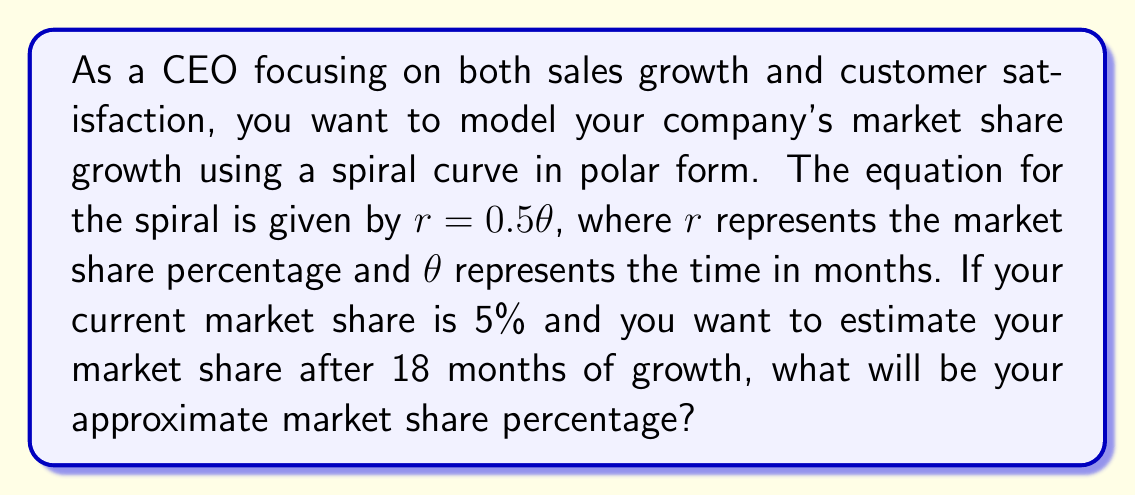Give your solution to this math problem. To solve this problem, we need to follow these steps:

1) The spiral equation is given in polar form as $r = 0.5\theta$

2) We need to find $r$ when $\theta = 18$ (as we want to estimate the market share after 18 months)

3) Substitute $\theta = 18$ into the equation:
   
   $r = 0.5 \cdot 18 = 9$

4) This means that after 18 months, the spiral will have grown by 9 percentage points.

5) However, we started with a 5% market share, so we need to add this to our result:

   Final market share = Initial market share + Growth
                      = 5% + 9% = 14%

Therefore, after 18 months, the estimated market share will be approximately 14%.

[asy]
import graph;
size(200);
real f(real t) {return 0.5*t;}
draw(polargraph(f,0,6*pi,operator ..),blue);
dot((5,0),red);
dot((14,18*pi/30),red);
label("Start (5%)",(5,0),E);
label("18 months (14%)",(14,18*pi/30),NE);
[/asy]
Answer: The approximate market share after 18 months will be 14%. 